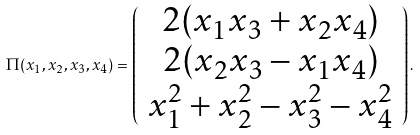<formula> <loc_0><loc_0><loc_500><loc_500>\Pi ( x _ { 1 } , x _ { 2 } , x _ { 3 } , x _ { 4 } ) = \left ( \begin{array} [ ] { c } 2 ( x _ { 1 } x _ { 3 } + x _ { 2 } x _ { 4 } ) \\ 2 ( x _ { 2 } x _ { 3 } - x _ { 1 } x _ { 4 } ) \\ x _ { 1 } ^ { 2 } + x _ { 2 } ^ { 2 } - x _ { 3 } ^ { 2 } - x _ { 4 } ^ { 2 } \end{array} \right ) .</formula> 